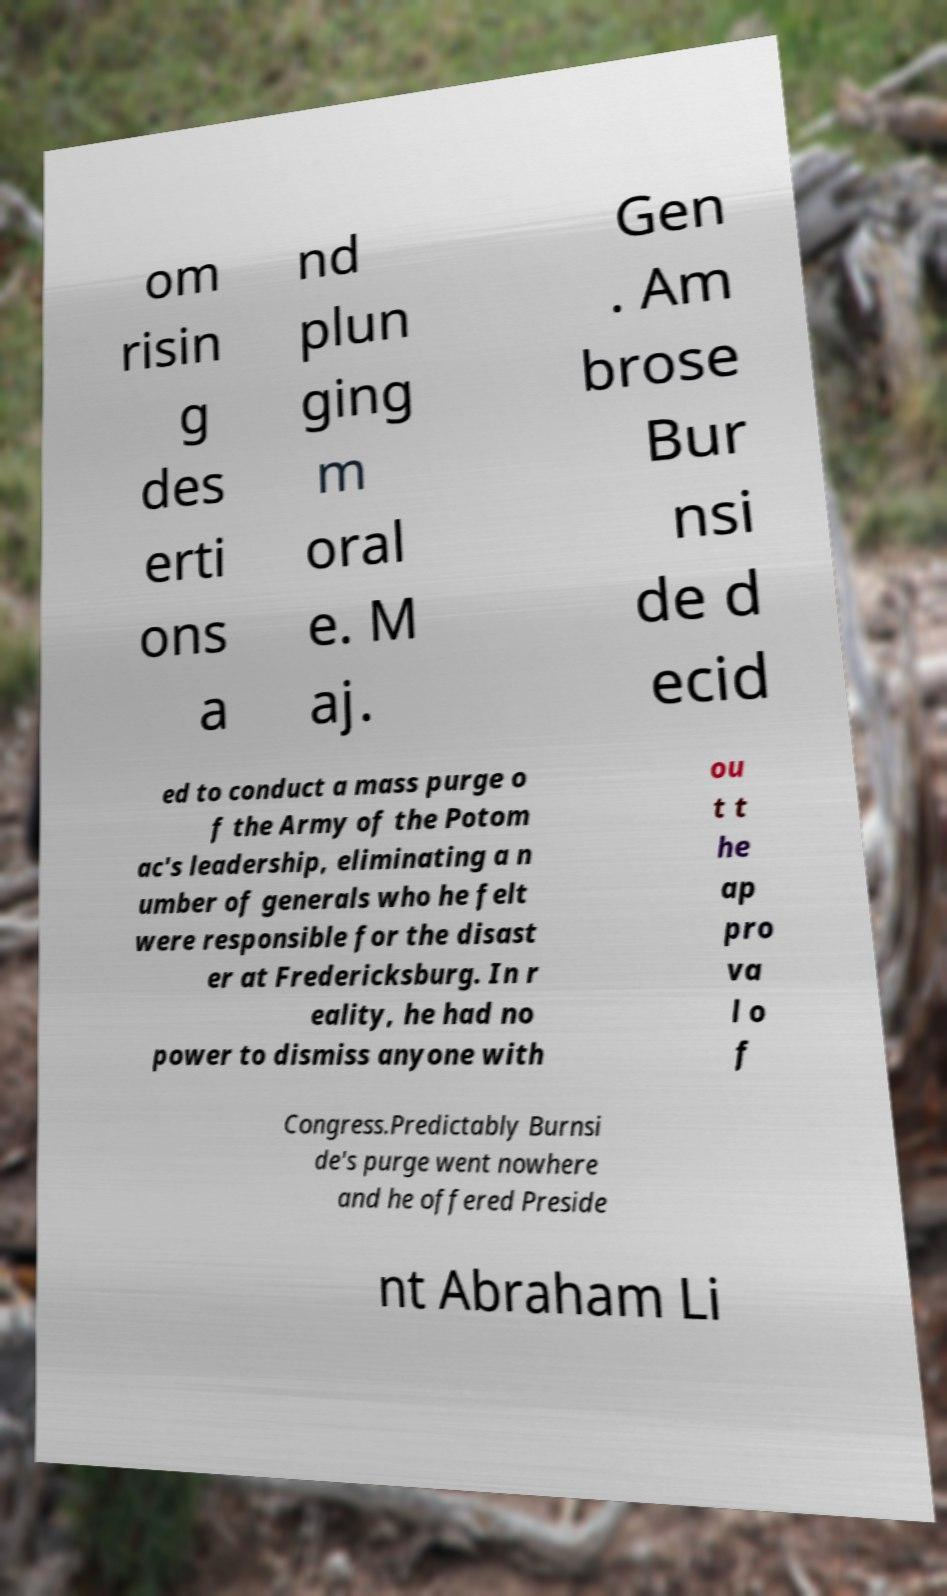Can you accurately transcribe the text from the provided image for me? om risin g des erti ons a nd plun ging m oral e. M aj. Gen . Am brose Bur nsi de d ecid ed to conduct a mass purge o f the Army of the Potom ac's leadership, eliminating a n umber of generals who he felt were responsible for the disast er at Fredericksburg. In r eality, he had no power to dismiss anyone with ou t t he ap pro va l o f Congress.Predictably Burnsi de's purge went nowhere and he offered Preside nt Abraham Li 